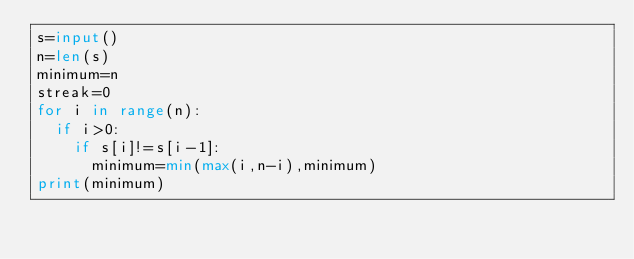Convert code to text. <code><loc_0><loc_0><loc_500><loc_500><_Python_>s=input()
n=len(s)
minimum=n
streak=0
for i in range(n):
  if i>0:
    if s[i]!=s[i-1]:
      minimum=min(max(i,n-i),minimum)
print(minimum)</code> 